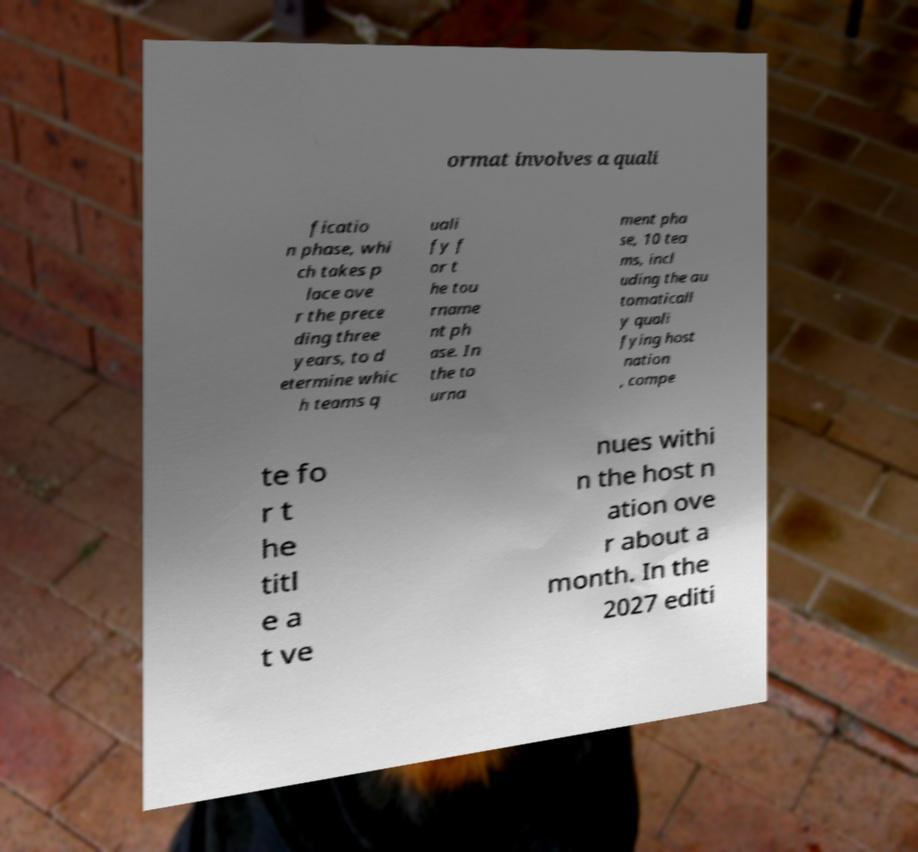Please identify and transcribe the text found in this image. ormat involves a quali ficatio n phase, whi ch takes p lace ove r the prece ding three years, to d etermine whic h teams q uali fy f or t he tou rname nt ph ase. In the to urna ment pha se, 10 tea ms, incl uding the au tomaticall y quali fying host nation , compe te fo r t he titl e a t ve nues withi n the host n ation ove r about a month. In the 2027 editi 